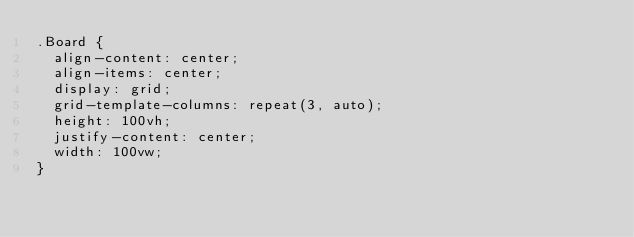<code> <loc_0><loc_0><loc_500><loc_500><_CSS_>.Board {
  align-content: center;
  align-items: center;
  display: grid;
  grid-template-columns: repeat(3, auto);
  height: 100vh;
  justify-content: center;
  width: 100vw;
}</code> 